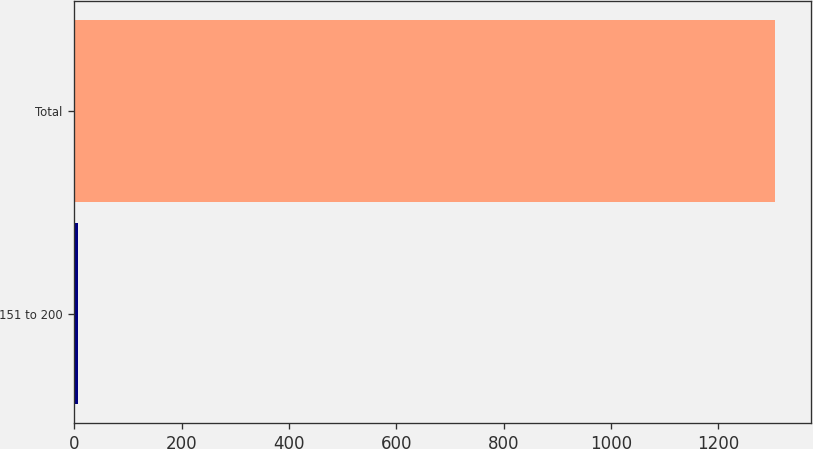<chart> <loc_0><loc_0><loc_500><loc_500><bar_chart><fcel>151 to 200<fcel>Total<nl><fcel>7.1<fcel>1306.7<nl></chart> 